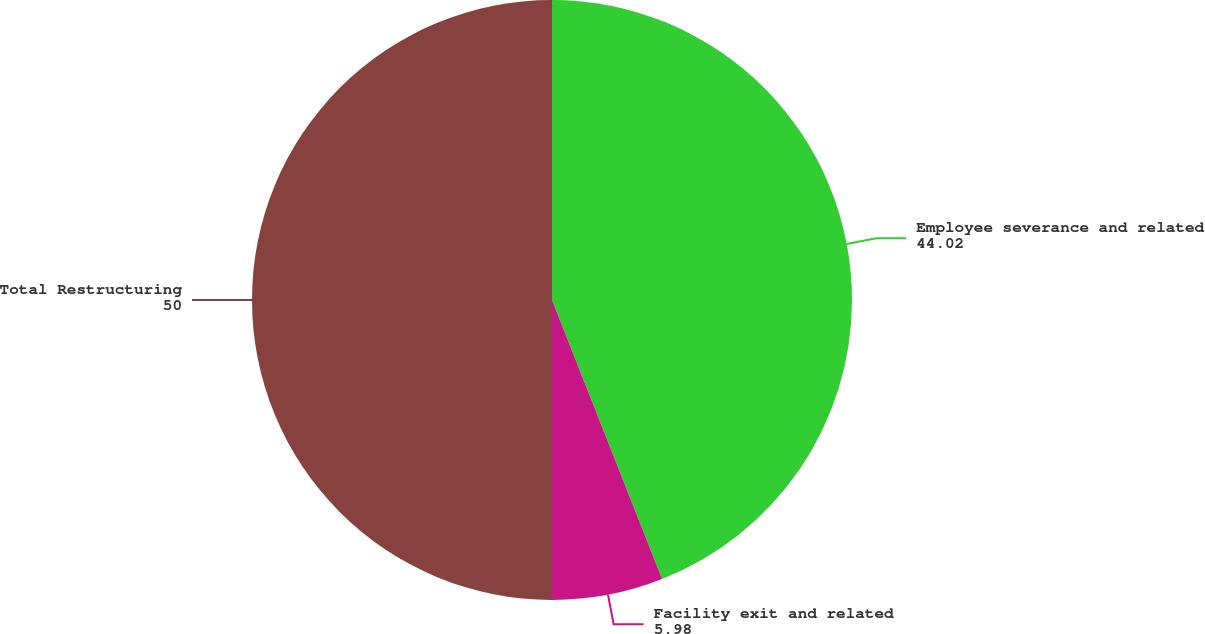Convert chart to OTSL. <chart><loc_0><loc_0><loc_500><loc_500><pie_chart><fcel>Employee severance and related<fcel>Facility exit and related<fcel>Total Restructuring<nl><fcel>44.02%<fcel>5.98%<fcel>50.0%<nl></chart> 